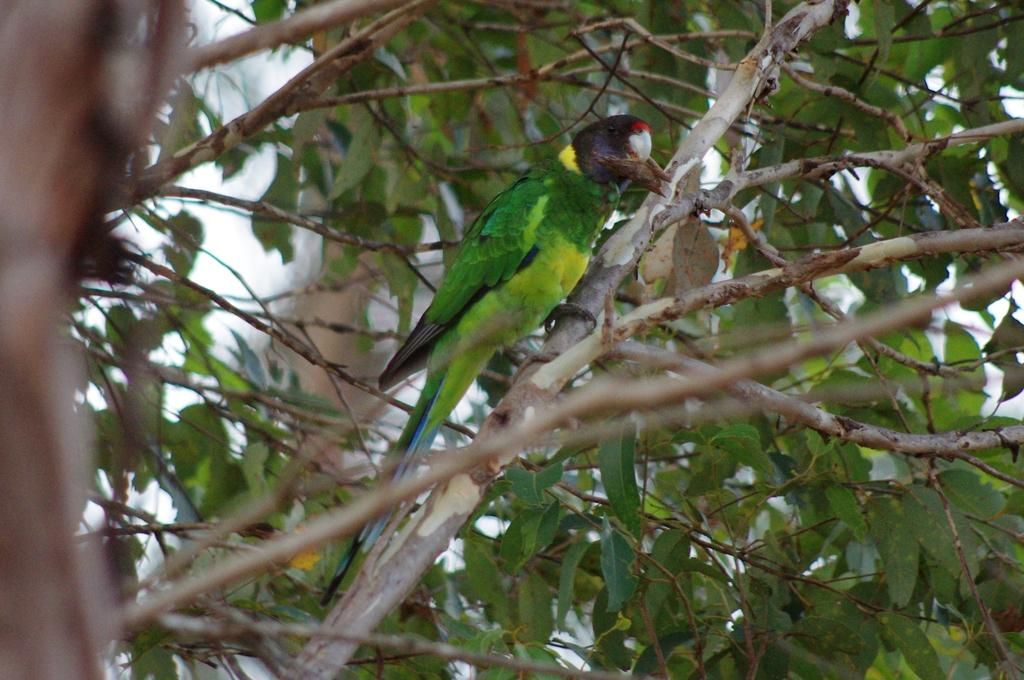What type of animal can be seen in the image? There is a bird in the image. Where is the bird located in the image? The bird is on a tree branch. What type of yam is being used as a news source in the image? There is no yam or news source present in the image; it features a bird on a tree branch. 